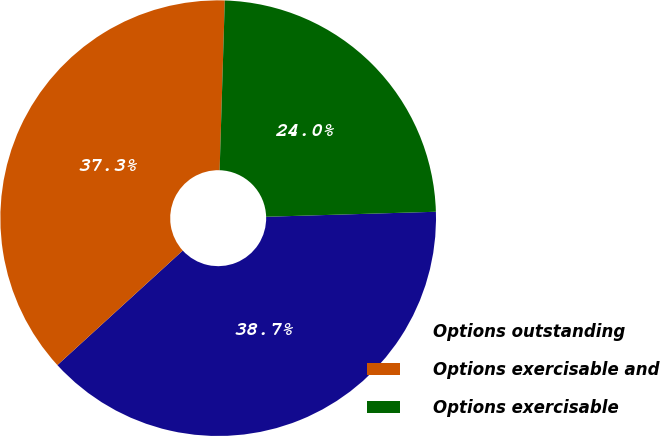Convert chart. <chart><loc_0><loc_0><loc_500><loc_500><pie_chart><fcel>Options outstanding<fcel>Options exercisable and<fcel>Options exercisable<nl><fcel>38.69%<fcel>37.27%<fcel>24.05%<nl></chart> 